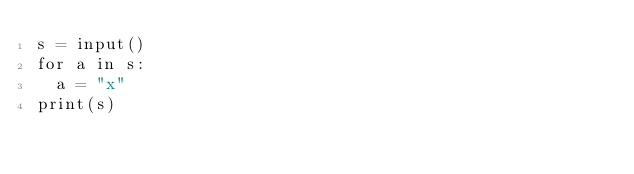<code> <loc_0><loc_0><loc_500><loc_500><_Python_>s = input()
for a in s:
  a = "x"
print(s)</code> 